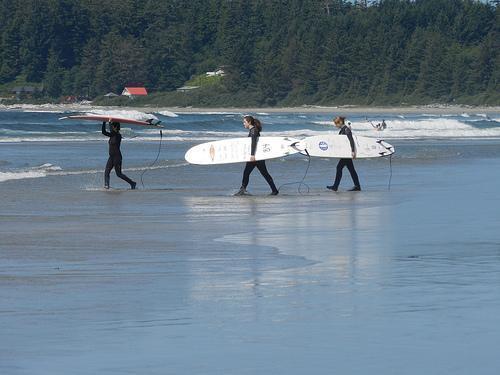How many white surf boards are there?
Give a very brief answer. 3. How many people are holding surf boards?
Give a very brief answer. 3. How many people are carrying their surf boards over their head?
Give a very brief answer. 1. 